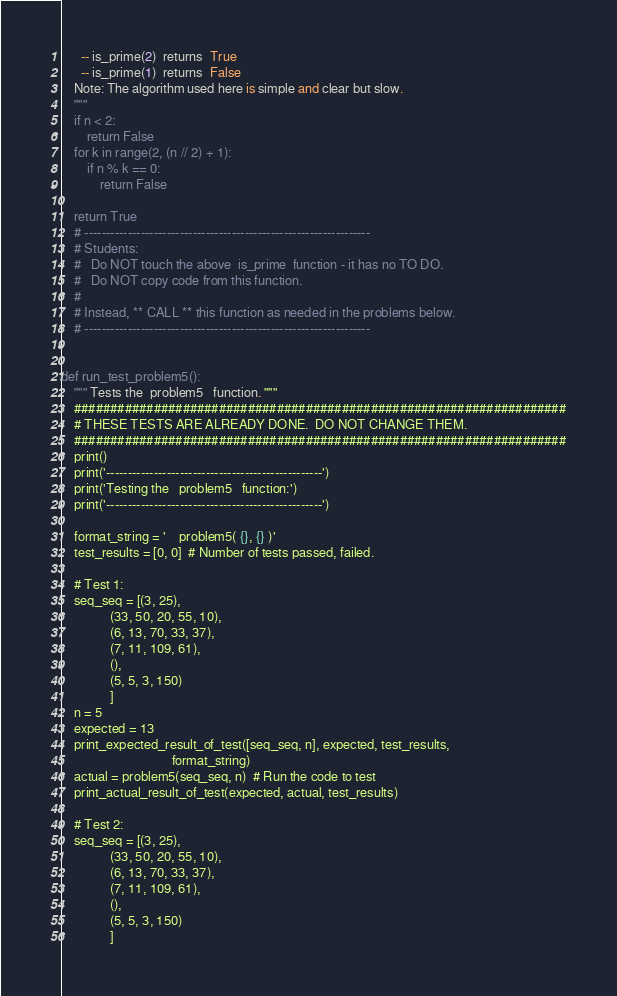Convert code to text. <code><loc_0><loc_0><loc_500><loc_500><_Python_>      -- is_prime(2)  returns  True
      -- is_prime(1)  returns  False
    Note: The algorithm used here is simple and clear but slow.
    """
    if n < 2:
        return False
    for k in range(2, (n // 2) + 1):
        if n % k == 0:
            return False

    return True
    # ------------------------------------------------------------------
    # Students:
    #   Do NOT touch the above  is_prime  function - it has no TO DO.
    #   Do NOT copy code from this function.
    #
    # Instead, ** CALL ** this function as needed in the problems below.
    # ------------------------------------------------------------------


def run_test_problem5():
    """ Tests the  problem5   function. """
    ####################################################################
    # THESE TESTS ARE ALREADY DONE.  DO NOT CHANGE THEM.
    ####################################################################
    print()
    print('--------------------------------------------------')
    print('Testing the   problem5   function:')
    print('--------------------------------------------------')

    format_string = '    problem5( {}, {} )'
    test_results = [0, 0]  # Number of tests passed, failed.

    # Test 1:
    seq_seq = [(3, 25),
               (33, 50, 20, 55, 10),
               (6, 13, 70, 33, 37),
               (7, 11, 109, 61),
               (),
               (5, 5, 3, 150)
               ]
    n = 5
    expected = 13
    print_expected_result_of_test([seq_seq, n], expected, test_results,
                                  format_string)
    actual = problem5(seq_seq, n)  # Run the code to test
    print_actual_result_of_test(expected, actual, test_results)

    # Test 2:
    seq_seq = [(3, 25),
               (33, 50, 20, 55, 10),
               (6, 13, 70, 33, 37),
               (7, 11, 109, 61),
               (),
               (5, 5, 3, 150)
               ]</code> 